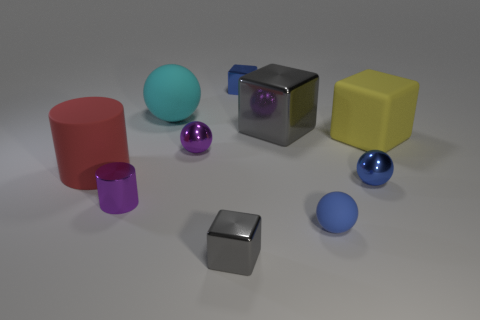Subtract 1 balls. How many balls are left? 3 Subtract all balls. How many objects are left? 6 Subtract 0 yellow cylinders. How many objects are left? 10 Subtract all blue cylinders. Subtract all large gray objects. How many objects are left? 9 Add 5 blue metallic blocks. How many blue metallic blocks are left? 6 Add 1 small brown matte objects. How many small brown matte objects exist? 1 